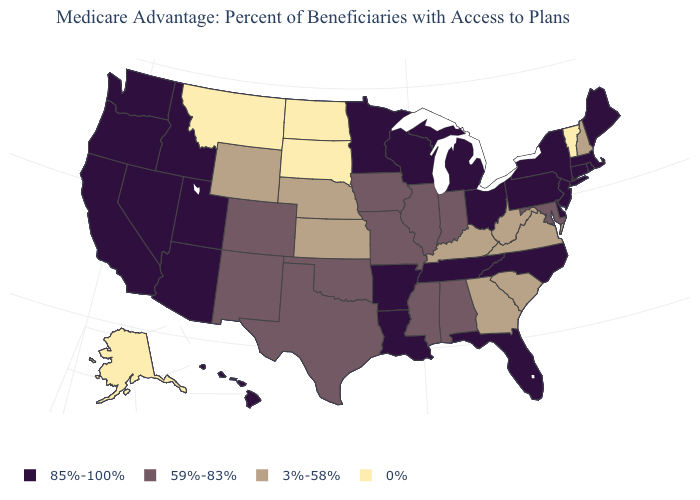What is the lowest value in the West?
Keep it brief. 0%. Name the states that have a value in the range 0%?
Concise answer only. Alaska, Montana, North Dakota, South Dakota, Vermont. Which states have the highest value in the USA?
Short answer required. Arkansas, Arizona, California, Connecticut, Delaware, Florida, Hawaii, Idaho, Louisiana, Massachusetts, Maine, Michigan, Minnesota, North Carolina, New Jersey, Nevada, New York, Ohio, Oregon, Pennsylvania, Rhode Island, Tennessee, Utah, Washington, Wisconsin. Name the states that have a value in the range 0%?
Keep it brief. Alaska, Montana, North Dakota, South Dakota, Vermont. Is the legend a continuous bar?
Keep it brief. No. Name the states that have a value in the range 85%-100%?
Concise answer only. Arkansas, Arizona, California, Connecticut, Delaware, Florida, Hawaii, Idaho, Louisiana, Massachusetts, Maine, Michigan, Minnesota, North Carolina, New Jersey, Nevada, New York, Ohio, Oregon, Pennsylvania, Rhode Island, Tennessee, Utah, Washington, Wisconsin. How many symbols are there in the legend?
Give a very brief answer. 4. Does the first symbol in the legend represent the smallest category?
Be succinct. No. What is the value of Rhode Island?
Short answer required. 85%-100%. Name the states that have a value in the range 0%?
Keep it brief. Alaska, Montana, North Dakota, South Dakota, Vermont. Name the states that have a value in the range 3%-58%?
Short answer required. Georgia, Kansas, Kentucky, Nebraska, New Hampshire, South Carolina, Virginia, West Virginia, Wyoming. Name the states that have a value in the range 85%-100%?
Short answer required. Arkansas, Arizona, California, Connecticut, Delaware, Florida, Hawaii, Idaho, Louisiana, Massachusetts, Maine, Michigan, Minnesota, North Carolina, New Jersey, Nevada, New York, Ohio, Oregon, Pennsylvania, Rhode Island, Tennessee, Utah, Washington, Wisconsin. What is the highest value in the USA?
Be succinct. 85%-100%. How many symbols are there in the legend?
Short answer required. 4. Name the states that have a value in the range 85%-100%?
Short answer required. Arkansas, Arizona, California, Connecticut, Delaware, Florida, Hawaii, Idaho, Louisiana, Massachusetts, Maine, Michigan, Minnesota, North Carolina, New Jersey, Nevada, New York, Ohio, Oregon, Pennsylvania, Rhode Island, Tennessee, Utah, Washington, Wisconsin. 